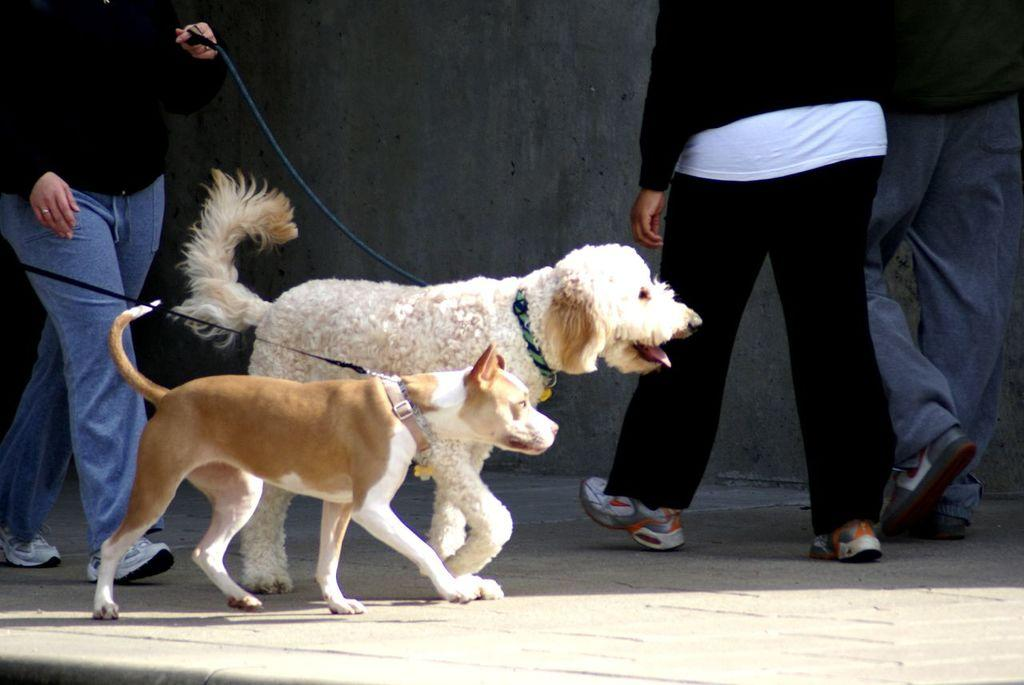How many dogs are present in the image? There are two dogs in the image. Where are the dogs located? The dogs are on the road. Is there anyone with the dogs in the image? Yes, there is a person holding a dog chain in the image. What can be seen in the background of the image? There is a wall visible in the background of the image. What type of eggnog is being served to the dogs in the image? There is no eggnog present in the image; it features two dogs on the road with a person holding a dog chain. How does the ring fit into the image? There is no ring present in the image. 